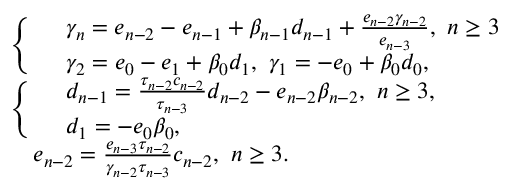Convert formula to latex. <formula><loc_0><loc_0><loc_500><loc_500>\begin{array} { r l } & { \left \{ \begin{array} { r l } & { \gamma _ { n } = e _ { n - 2 } - e _ { n - 1 } + \beta _ { n - 1 } d _ { n - 1 } + \frac { e _ { n - 2 } \gamma _ { n - 2 } } { e _ { n - 3 } } , n \geq 3 } \\ & { \gamma _ { 2 } = e _ { 0 } - e _ { 1 } + \beta _ { 0 } d _ { 1 } , \gamma _ { 1 } = - e _ { 0 } + \beta _ { 0 } d _ { 0 } , } \end{array} } \\ & { \left \{ \begin{array} { r l } & { d _ { n - 1 } = \frac { \tau _ { n - 2 } c _ { n - 2 } } { \tau _ { n - 3 } } d _ { n - 2 } - e _ { n - 2 } \beta _ { n - 2 } , n \geq 3 , } \\ & { d _ { 1 } = - e _ { 0 } \beta _ { 0 } , } \end{array} } \\ & { e _ { n - 2 } = \frac { e _ { n - 3 } \tau _ { n - 2 } } { \gamma _ { n - 2 } \tau _ { n - 3 } } c _ { n - 2 } , n \geq 3 . } \end{array}</formula> 